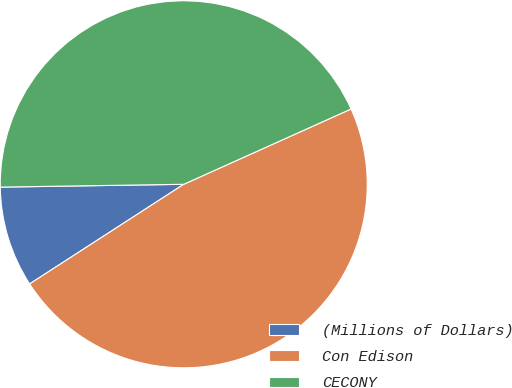<chart> <loc_0><loc_0><loc_500><loc_500><pie_chart><fcel>(Millions of Dollars)<fcel>Con Edison<fcel>CECONY<nl><fcel>8.89%<fcel>47.59%<fcel>43.51%<nl></chart> 